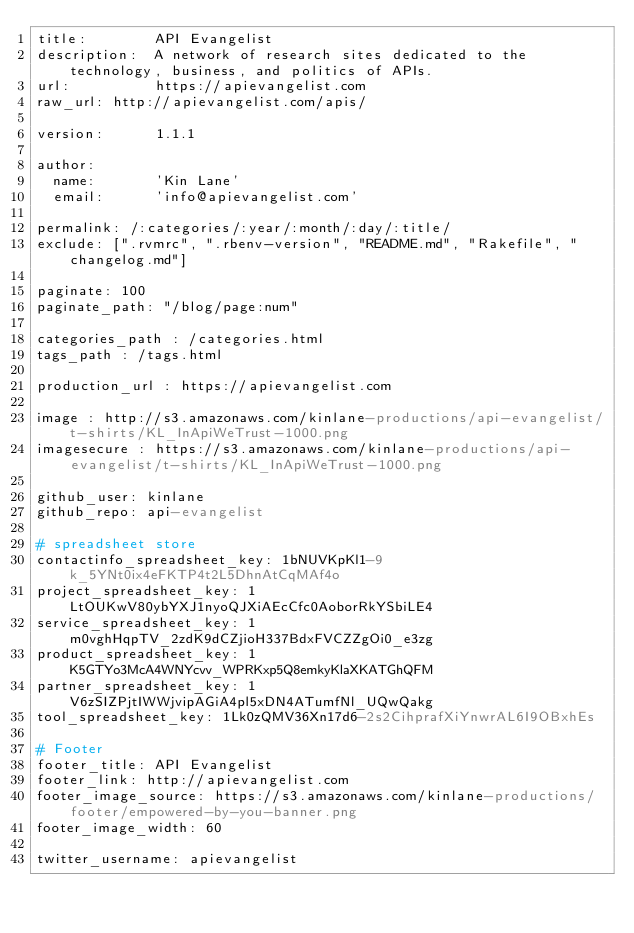Convert code to text. <code><loc_0><loc_0><loc_500><loc_500><_YAML_>title:        API Evangelist
description:  A network of research sites dedicated to the technology, business, and politics of APIs.
url:          https://apievangelist.com
raw_url: http://apievangelist.com/apis/

version:      1.1.1

author:
  name:       'Kin Lane'
  email:      'info@apievangelist.com'

permalink: /:categories/:year/:month/:day/:title/
exclude: [".rvmrc", ".rbenv-version", "README.md", "Rakefile", "changelog.md"]

paginate: 100
paginate_path: "/blog/page:num"

categories_path : /categories.html
tags_path : /tags.html

production_url : https://apievangelist.com

image : http://s3.amazonaws.com/kinlane-productions/api-evangelist/t-shirts/KL_InApiWeTrust-1000.png
imagesecure : https://s3.amazonaws.com/kinlane-productions/api-evangelist/t-shirts/KL_InApiWeTrust-1000.png

github_user: kinlane
github_repo: api-evangelist

# spreadsheet store
contactinfo_spreadsheet_key: 1bNUVKpKl1-9k_5YNt0ix4eFKTP4t2L5DhnAtCqMAf4o
project_spreadsheet_key: 1LtOUKwV80ybYXJ1nyoQJXiAEcCfc0AoborRkYSbiLE4
service_spreadsheet_key: 1m0vghHqpTV_2zdK9dCZjioH337BdxFVCZZgOi0_e3zg
product_spreadsheet_key: 1K5GTYo3McA4WNYcvv_WPRKxp5Q8emkyKlaXKATGhQFM
partner_spreadsheet_key: 1V6zSIZPjtIWWjvipAGiA4pl5xDN4ATumfNl_UQwQakg
tool_spreadsheet_key: 1Lk0zQMV36Xn17d6-2s2CihprafXiYnwrAL6I9OBxhEs

# Footer
footer_title: API Evangelist
footer_link: http://apievangelist.com
footer_image_source: https://s3.amazonaws.com/kinlane-productions/footer/empowered-by-you-banner.png
footer_image_width: 60

twitter_username: apievangelist
</code> 